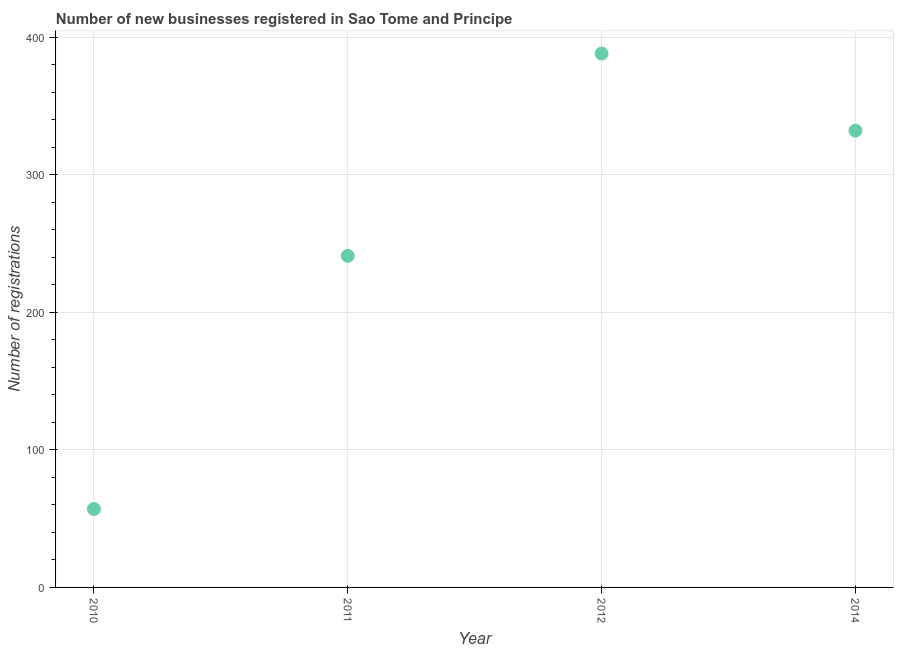What is the number of new business registrations in 2014?
Make the answer very short. 332. Across all years, what is the maximum number of new business registrations?
Your response must be concise. 388. Across all years, what is the minimum number of new business registrations?
Offer a very short reply. 57. In which year was the number of new business registrations maximum?
Offer a very short reply. 2012. What is the sum of the number of new business registrations?
Your answer should be compact. 1018. What is the difference between the number of new business registrations in 2012 and 2014?
Ensure brevity in your answer.  56. What is the average number of new business registrations per year?
Your answer should be compact. 254.5. What is the median number of new business registrations?
Your response must be concise. 286.5. In how many years, is the number of new business registrations greater than 20 ?
Keep it short and to the point. 4. Do a majority of the years between 2011 and 2010 (inclusive) have number of new business registrations greater than 20 ?
Keep it short and to the point. No. What is the ratio of the number of new business registrations in 2010 to that in 2014?
Keep it short and to the point. 0.17. Is the difference between the number of new business registrations in 2011 and 2014 greater than the difference between any two years?
Your answer should be compact. No. Is the sum of the number of new business registrations in 2011 and 2014 greater than the maximum number of new business registrations across all years?
Your answer should be very brief. Yes. What is the difference between the highest and the lowest number of new business registrations?
Offer a very short reply. 331. Does the number of new business registrations monotonically increase over the years?
Make the answer very short. No. What is the difference between two consecutive major ticks on the Y-axis?
Provide a succinct answer. 100. Does the graph contain any zero values?
Provide a succinct answer. No. What is the title of the graph?
Make the answer very short. Number of new businesses registered in Sao Tome and Principe. What is the label or title of the X-axis?
Give a very brief answer. Year. What is the label or title of the Y-axis?
Your answer should be very brief. Number of registrations. What is the Number of registrations in 2010?
Provide a short and direct response. 57. What is the Number of registrations in 2011?
Your answer should be very brief. 241. What is the Number of registrations in 2012?
Ensure brevity in your answer.  388. What is the Number of registrations in 2014?
Your answer should be compact. 332. What is the difference between the Number of registrations in 2010 and 2011?
Provide a short and direct response. -184. What is the difference between the Number of registrations in 2010 and 2012?
Make the answer very short. -331. What is the difference between the Number of registrations in 2010 and 2014?
Offer a terse response. -275. What is the difference between the Number of registrations in 2011 and 2012?
Make the answer very short. -147. What is the difference between the Number of registrations in 2011 and 2014?
Your answer should be compact. -91. What is the difference between the Number of registrations in 2012 and 2014?
Provide a short and direct response. 56. What is the ratio of the Number of registrations in 2010 to that in 2011?
Provide a short and direct response. 0.24. What is the ratio of the Number of registrations in 2010 to that in 2012?
Offer a very short reply. 0.15. What is the ratio of the Number of registrations in 2010 to that in 2014?
Give a very brief answer. 0.17. What is the ratio of the Number of registrations in 2011 to that in 2012?
Offer a very short reply. 0.62. What is the ratio of the Number of registrations in 2011 to that in 2014?
Give a very brief answer. 0.73. What is the ratio of the Number of registrations in 2012 to that in 2014?
Your answer should be compact. 1.17. 